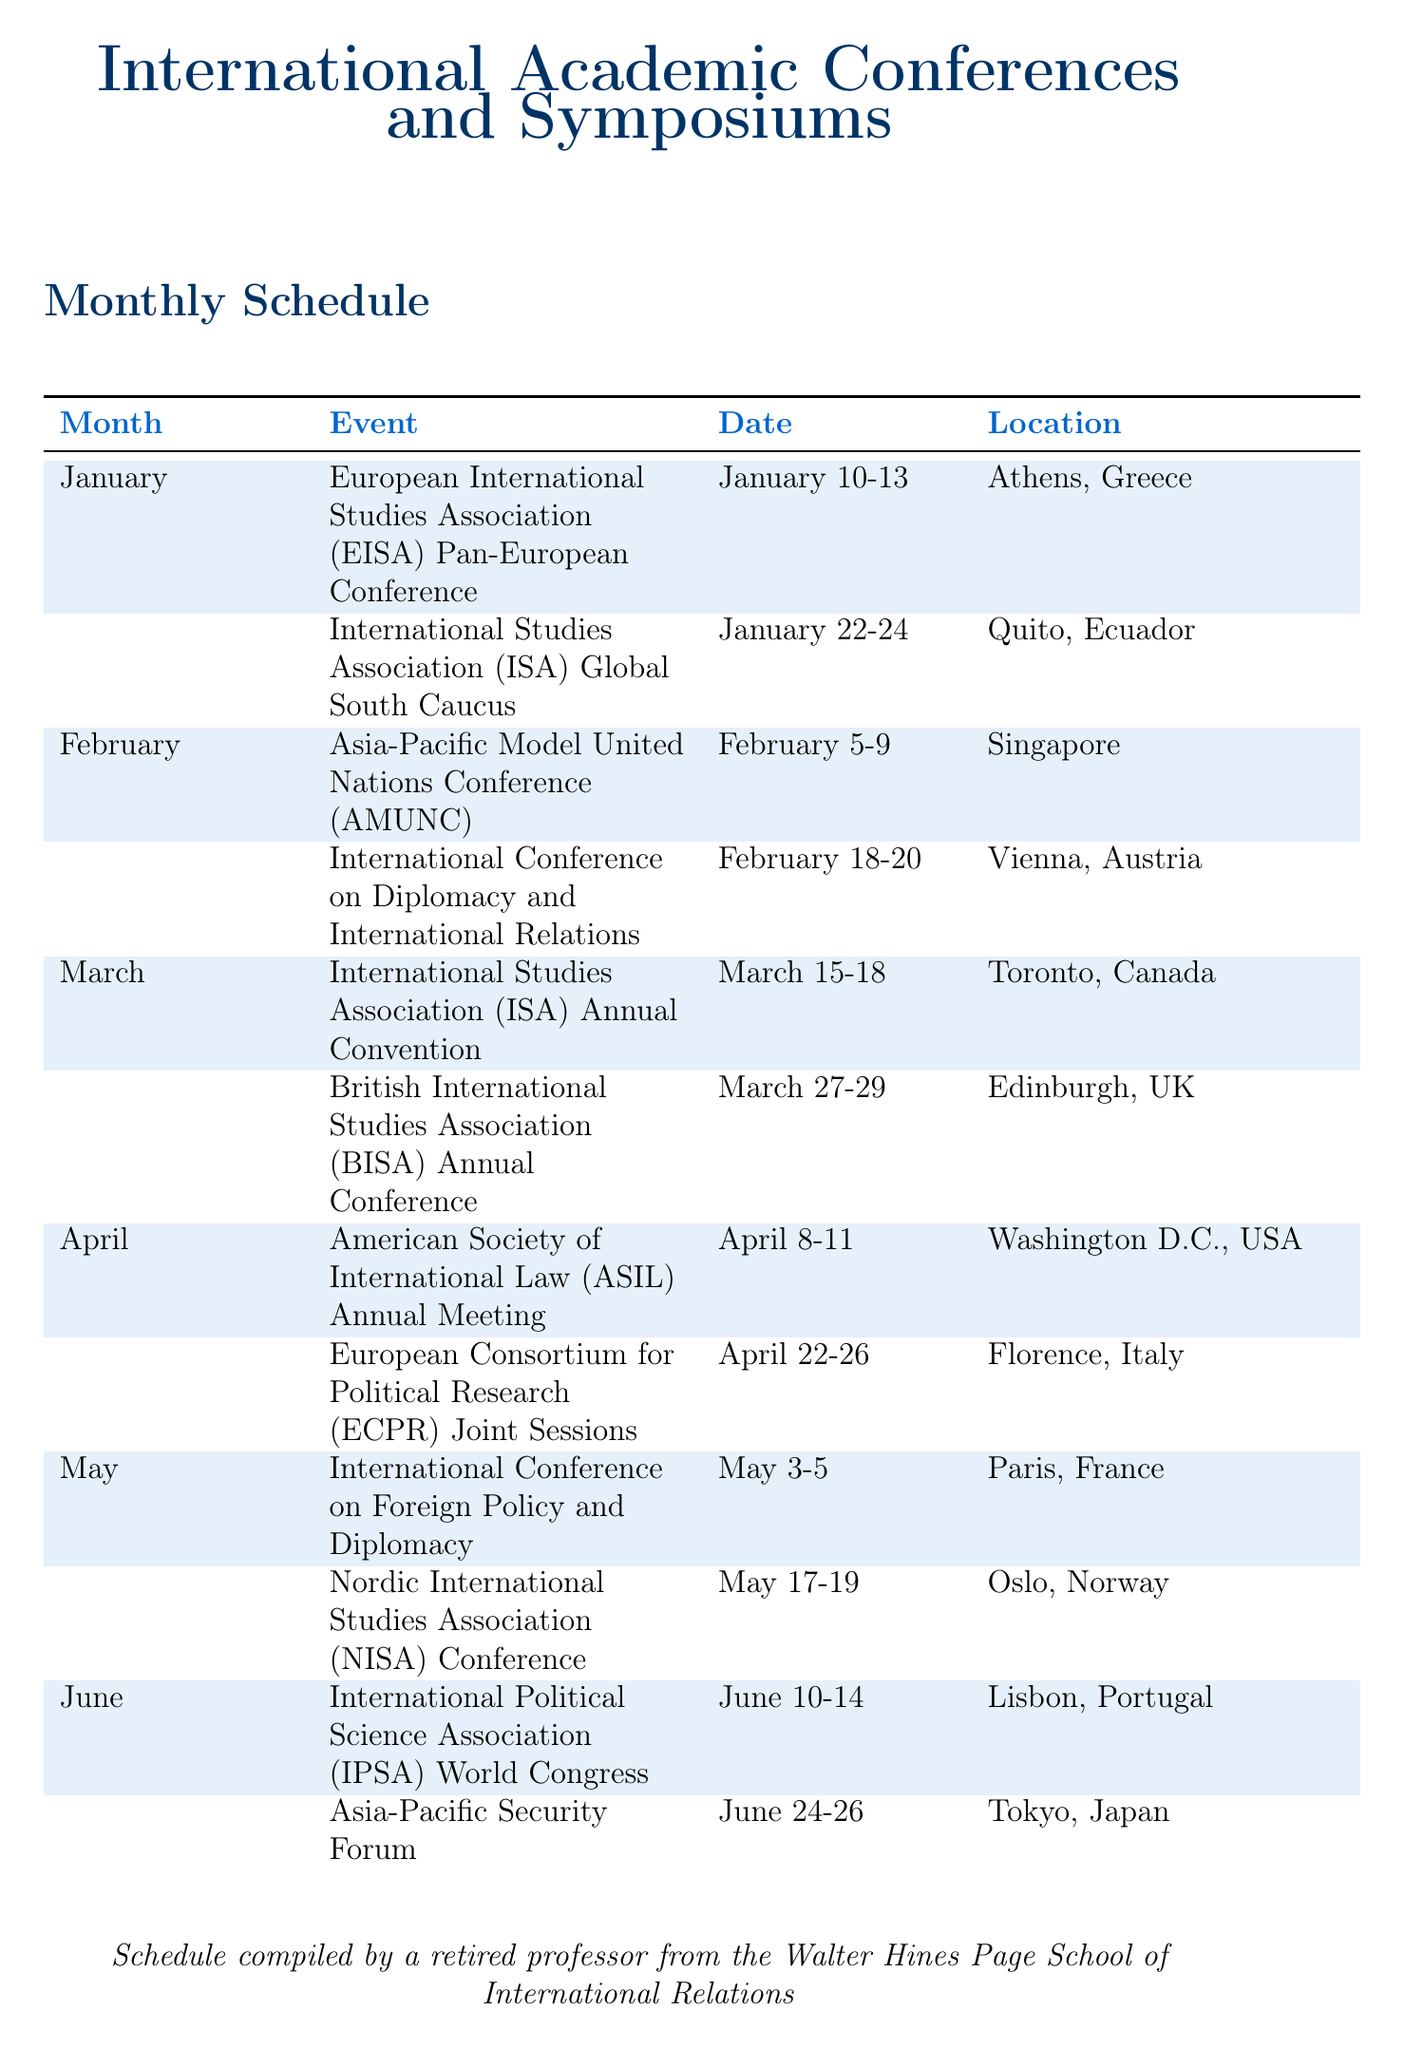What is the date of the EISA Pan-European Conference? The date of the event is provided in the document, listed as January 10-13.
Answer: January 10-13 Where is the International Studies Association (ISA) Global South Caucus held? The location is mentioned in the schedule, which states it is in Quito, Ecuador.
Answer: Quito, Ecuador What is the focus of the International Conference on Diplomacy and International Relations? The focus is specified in the document as Digital Diplomacy in the 21st Century.
Answer: Digital Diplomacy in the 21st Century How many conferences are scheduled in May? To determine this, count the events listed for May in the document, which shows two conferences.
Answer: 2 Which city hosts the Africans Studies Association (ASA) Annual Meeting? The location of the event is provided in the document, stating it is in Nairobi, Kenya.
Answer: Nairobi, Kenya What month has a conference focusing on Regional Security Challenges? The document lists the Asia-Pacific Security Forum in June, indicating it covers such challenges.
Answer: June Which conference occurs in the first half of December? The Global South International Studies Conference is noted to be held from December 5-7.
Answer: Global South International Studies Conference What is the primary theme of the ECPR General Conference? The document mentions the theme as European Integration and Global Politics.
Answer: European Integration and Global Politics How many international conferences are held in October? The document states that there are two conferences in October listed.
Answer: 2 